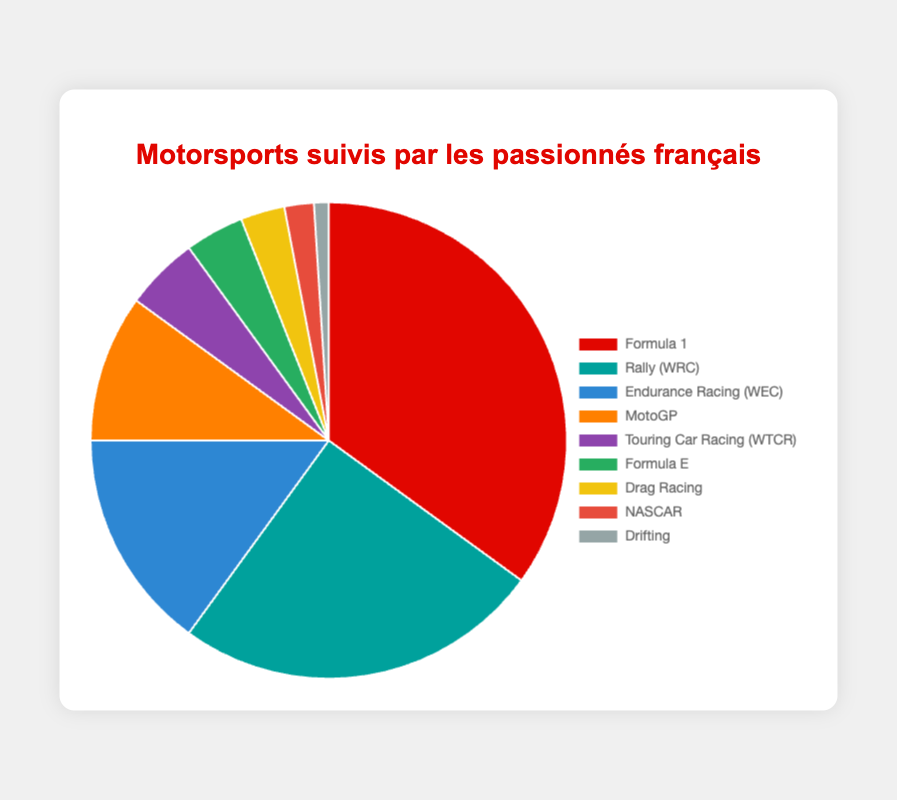Which motorsport has the highest following among French enthusiasts? By observing the pie chart, we can see that the section labeled "Formula 1" is the largest. This indicates that Formula 1 has the highest percentage of enthusiasts following it.
Answer: Formula 1 What is the combined percentage of MotoGP and Touring Car Racing (WTCR) followers? To find the combined percentage, we need to add the values for MotoGP (10%) and Touring Car Racing (WTCR) (5%). Thus, 10% + 5% = 15%.
Answer: 15% Among the listed motorsports, which has the smallest following, and what is its percentage? By seeing the smallest section on the pie chart, we can identify that "Drifting" has the smallest following. The percentage for Drifting is labeled as 1%.
Answer: Drifting, 1% What is the difference in percentage between Rally (WRC) and Formula E followers? We need to subtract the percentage of Formula E (4%) from the percentage of Rally (WRC) (25%). Thus, 25% - 4% = 21%.
Answer: 21% If we combine the followers of Formula E, Drag Racing, and NASCAR, what percentage do they account for? Adding the percentages for Formula E (4%), Drag Racing (3%), and NASCAR (2%), we get 4% + 3% + 2% = 9%.
Answer: 9% Is the percentage of Formula 1 followers greater than the total percentage of followers for Endurance Racing (WEC) and MotoGP? To determine this, we compare the percentage for Formula 1 (35%) with the combined percentage for Endurance Racing (WEC) (15%) and MotoGP (10%), which totals 25%. Since 35% is greater than 25%, the answer is yes.
Answer: Yes Which motorsport's segment is shown in blue on the pie chart? By referring to the color coding on the pie chart, we see that the blue section represents Endurance Racing (WEC).
Answer: Endurance Racing (WEC) How many motorsport categories have a following percentage less than 5%? By examining the segments with less than 5%: Formula E (4%), Drag Racing (3%), NASCAR (2%), and Drifting (1%), we find there are 4 categories below 5%.
Answer: 4 categories 